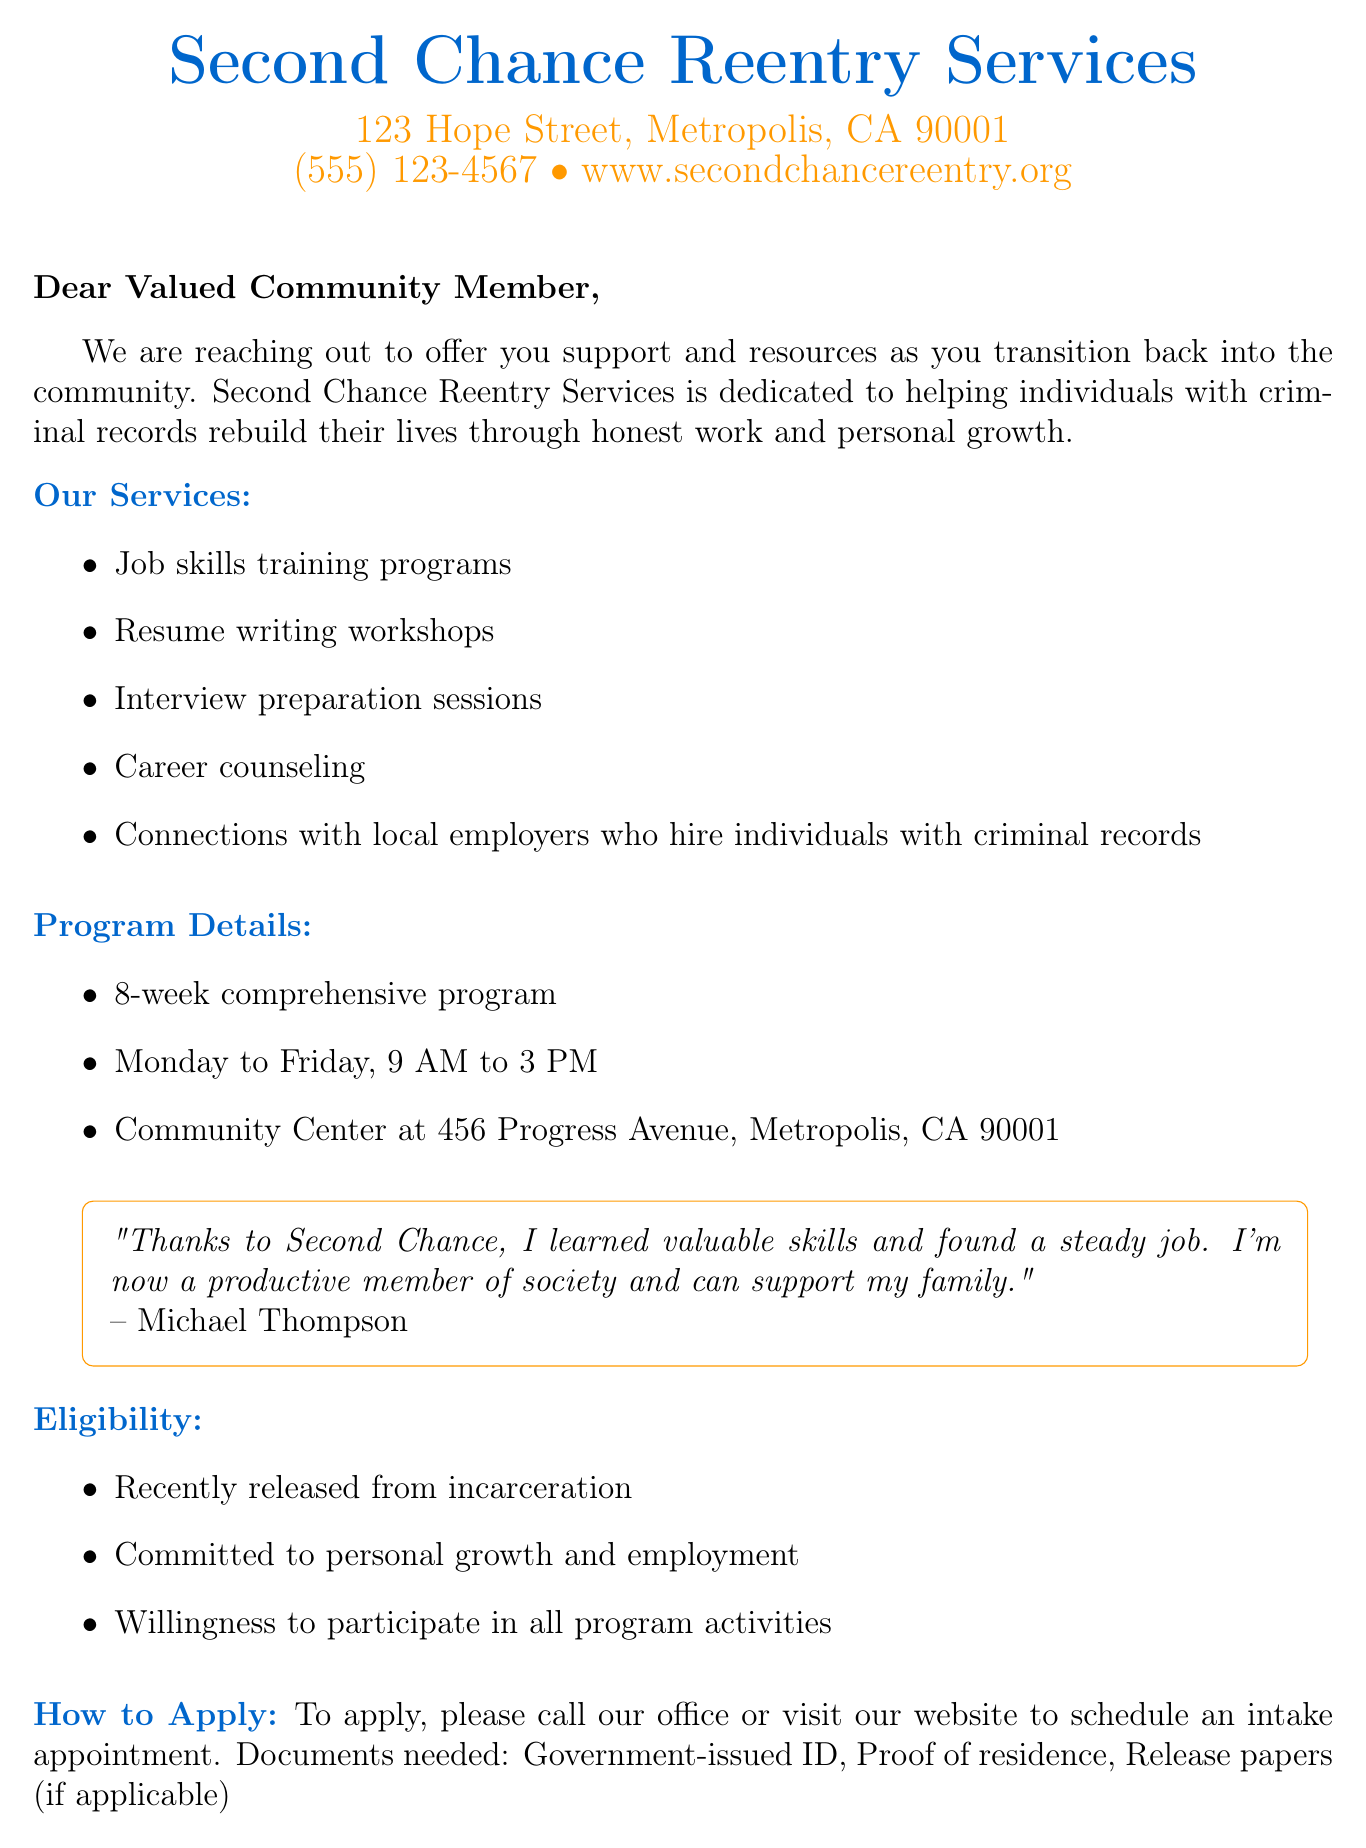What is the organization’s name? The organization's name is mentioned at the beginning of the letterhead.
Answer: Second Chance Reentry Services What is the phone number listed? The phone number is provided in the letterhead section for contact purposes.
Answer: (555) 123-4567 What are the program hours? The operating hours for the program are detailed in the program details section.
Answer: 9 AM to 3 PM Who is the program director? The name of the program director is provided at the closing of the letter.
Answer: Samantha Rodriguez How long is the program? The duration of the program is specified in the program details.
Answer: 8-week comprehensive program What is one of the eligibility requirements? Eligibility requirements are listed in a section, detailing what is needed to join the program.
Answer: Recently released from incarceration What type of training does the program offer? The services offered include various training sessions that are listed in the document.
Answer: Job skills training programs How can someone apply for the program? Instructions on applying are clearly stated in the document, indicating how to start the process.
Answer: Call our office or visit our website What is a success story mentioned in the document? A success story is cited in the letter, showcasing the impact of the program on individuals.
Answer: Michael Thompson 